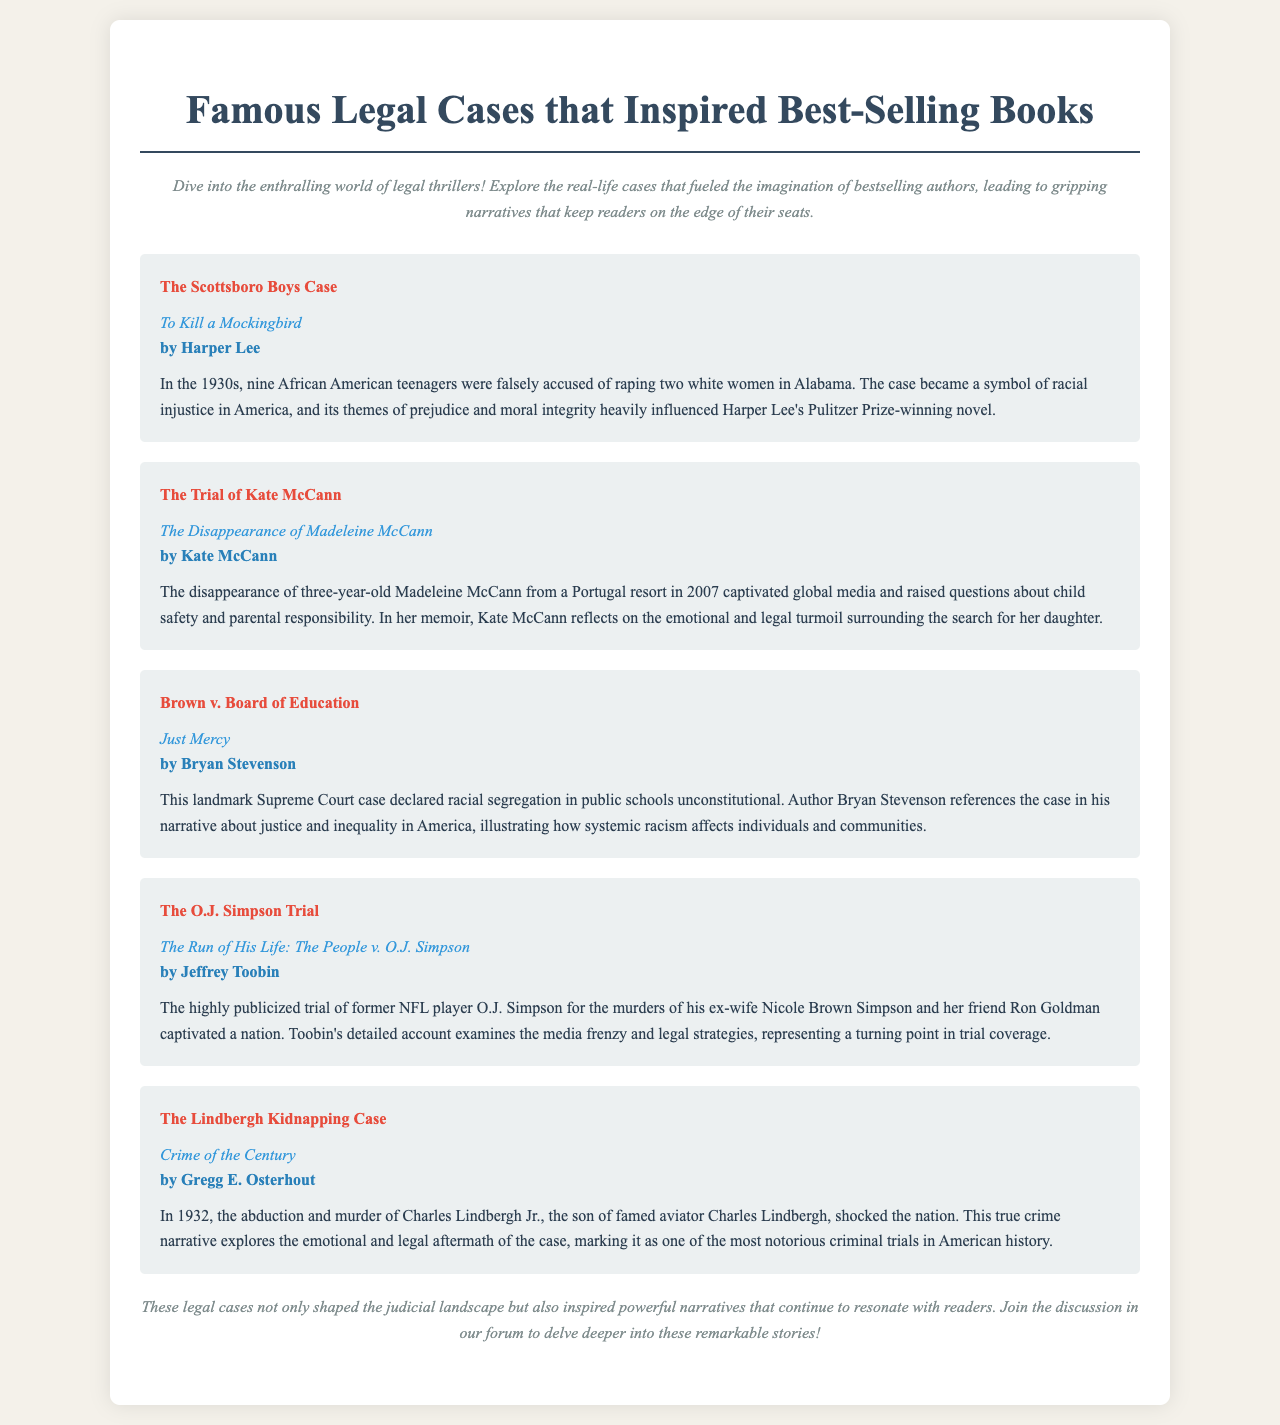What is the case that inspired "To Kill a Mockingbird"? The Scottsboro Boys Case is mentioned as the case that inspired Harper Lee's novel.
Answer: The Scottsboro Boys Case Who is the author of "Just Mercy"? The author, Bryan Stevenson, is listed in the document under "Just Mercy."
Answer: Bryan Stevenson What year did the disappearance of Madeleine McCann occur? The document states the disappearance happened in 2007.
Answer: 2007 Which trial involved O.J. Simpson? The document specifies The O.J. Simpson Trial as the significant trial involving O.J. Simpson.
Answer: The O.J. Simpson Trial What emotional theme does Kate McCann reflect on in her memoir? The memoir discusses emotional and legal turmoil surrounding her daughter’s disappearance.
Answer: Emotional and legal turmoil Which case is referenced in connection with racial segregation in the document? The document highlights Brown v. Board of Education as a case related to racial segregation.
Answer: Brown v. Board of Education What type of literary work is "Crime of the Century"? The document categorizes it as a true crime narrative.
Answer: True crime narrative What is the name of the book by Jeffrey Toobin? The document identifies the book as "The Run of His Life: The People v. O.J. Simpson."
Answer: The Run of His Life: The People v. O.J. Simpson 